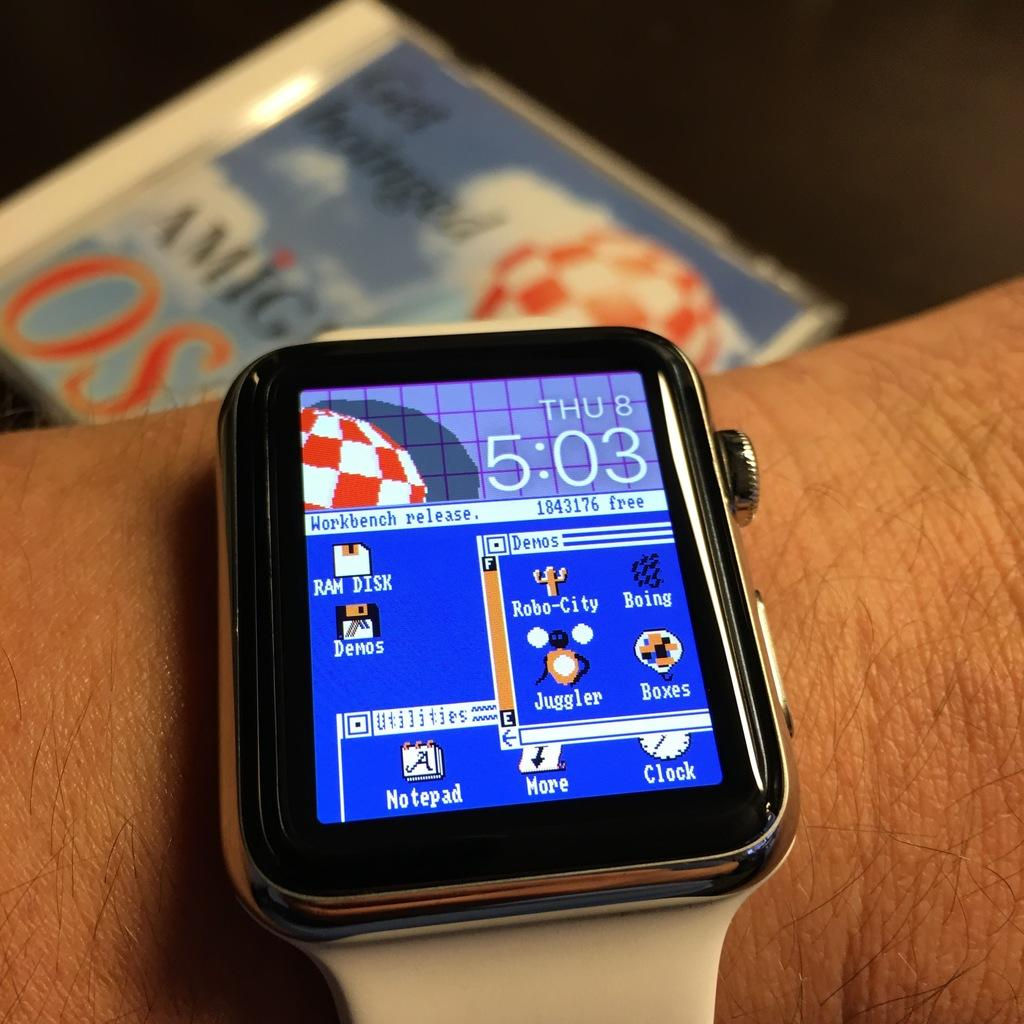<image>
Relay a brief, clear account of the picture shown. The display screen of a smart watch displays the time of 5:03 and the date of Thursday the 8th. 